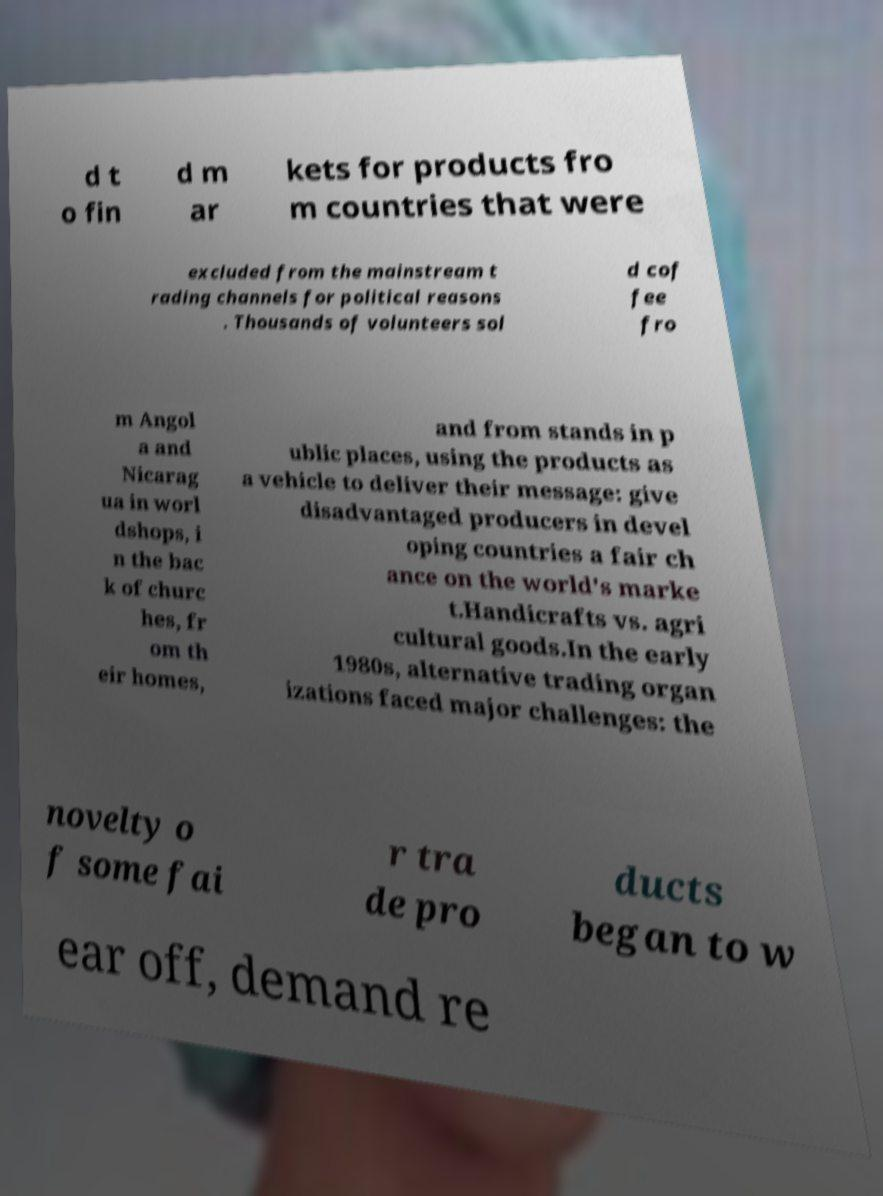There's text embedded in this image that I need extracted. Can you transcribe it verbatim? d t o fin d m ar kets for products fro m countries that were excluded from the mainstream t rading channels for political reasons . Thousands of volunteers sol d cof fee fro m Angol a and Nicarag ua in worl dshops, i n the bac k of churc hes, fr om th eir homes, and from stands in p ublic places, using the products as a vehicle to deliver their message: give disadvantaged producers in devel oping countries a fair ch ance on the world's marke t.Handicrafts vs. agri cultural goods.In the early 1980s, alternative trading organ izations faced major challenges: the novelty o f some fai r tra de pro ducts began to w ear off, demand re 